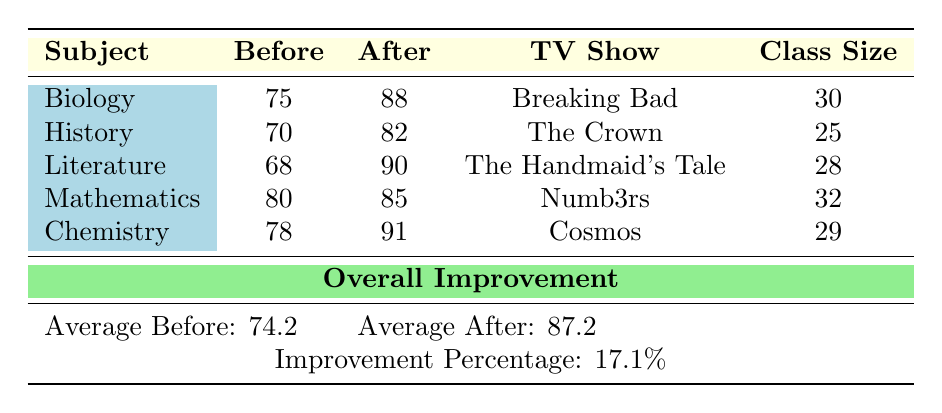What was the test score for Biology before integrating the TV show? The table shows that the score for Biology before integration was 75.
Answer: 75 What is the after score for Literature? According to the table, the after score for Literature is 90.
Answer: 90 Did the History class score higher after using 'The Crown'? Yes, the after score for History (82) is higher than the before score (70).
Answer: Yes What was the average score before the integration of TV shows? The average score before integration is calculated as (75 + 70 + 68 + 80 + 78) / 5 = 74.2.
Answer: 74.2 Which subject had the highest improvement? To determine which subject had the highest improvement, we find the differences: Biology (88 - 75 = 13), History (82 - 70 = 12), Literature (90 - 68 = 22), Mathematics (85 - 80 = 5), Chemistry (91 - 78 = 13). Literature had the highest improvement of 22 points.
Answer: Literature What is the overall improvement percentage across all subjects? The overall improvement percentage is given as 17.1%, calculated from the average scores of before (74.2) and after (87.2) as [(87.2 - 74.2) / 74.2] * 100 = 17.1%.
Answer: 17.1% Is the average after score for classes larger than 85? Yes, the average after score is 87.2, which is greater than 85.
Answer: Yes How many students were in the Mathematics class? Referring to the table, the Mathematics class had 32 students.
Answer: 32 Which TV show used in the classes had the lowest before score? The table shows that Literature had the lowest before score of 68, and it used 'The Handmaid's Tale.'
Answer: The Handmaid's Tale 